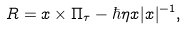<formula> <loc_0><loc_0><loc_500><loc_500>R = x \times \Pi _ { \tau } - \hbar { \eta } x | x | ^ { - 1 } ,</formula> 